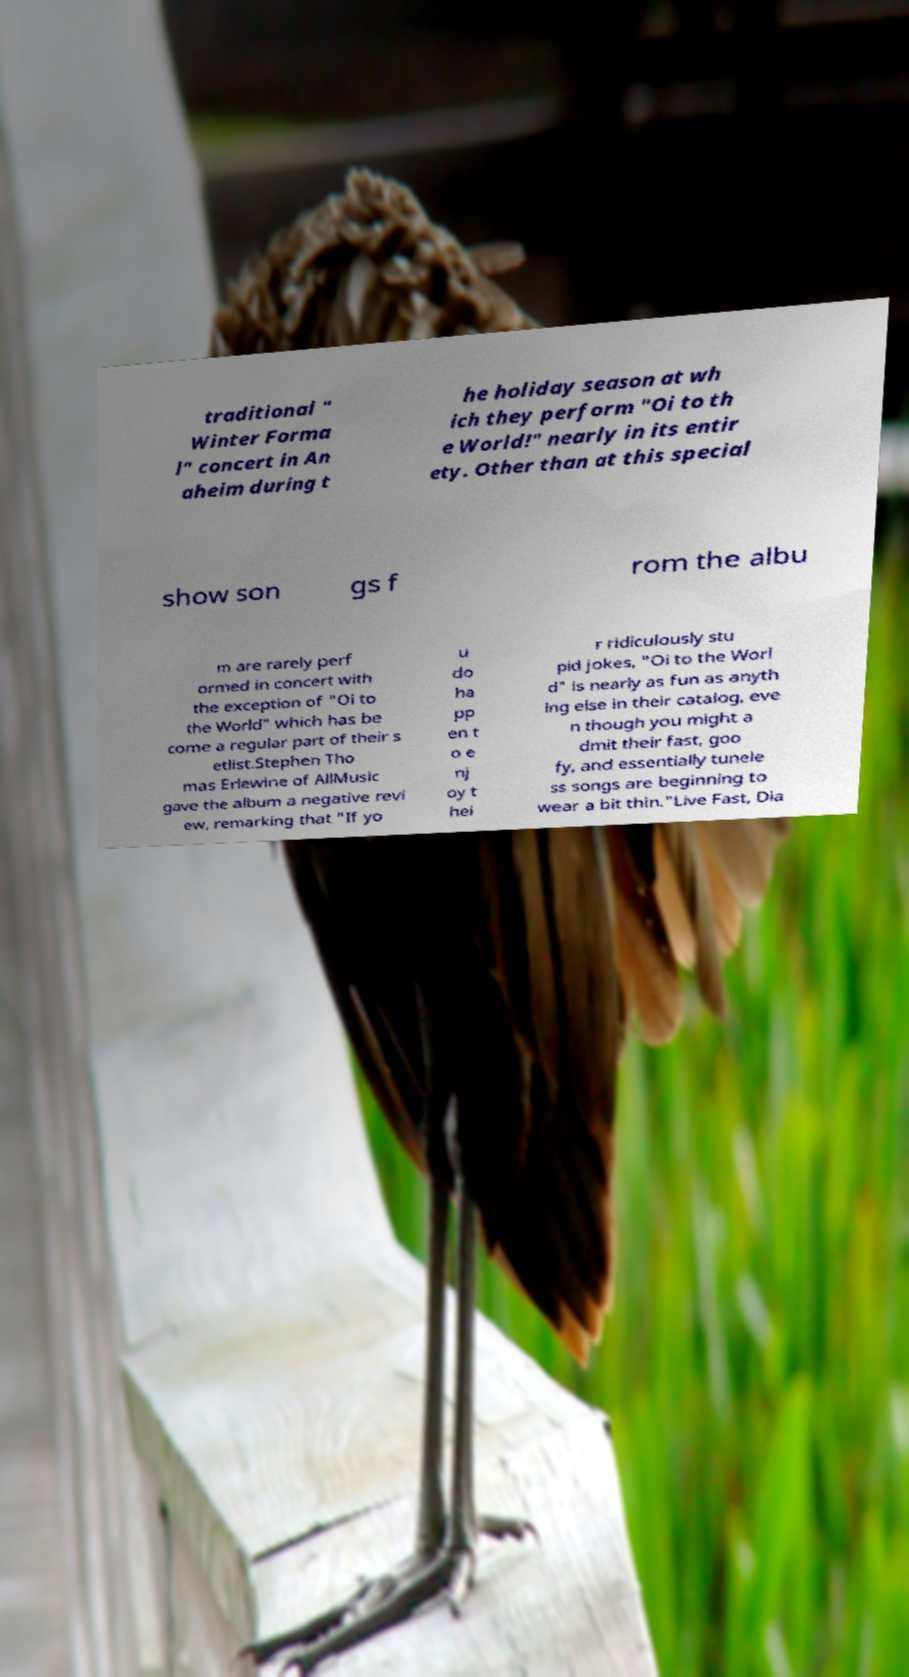I need the written content from this picture converted into text. Can you do that? traditional " Winter Forma l" concert in An aheim during t he holiday season at wh ich they perform "Oi to th e World!" nearly in its entir ety. Other than at this special show son gs f rom the albu m are rarely perf ormed in concert with the exception of "Oi to the World" which has be come a regular part of their s etlist.Stephen Tho mas Erlewine of AllMusic gave the album a negative revi ew, remarking that "If yo u do ha pp en t o e nj oy t hei r ridiculously stu pid jokes, "Oi to the Worl d" is nearly as fun as anyth ing else in their catalog, eve n though you might a dmit their fast, goo fy, and essentially tunele ss songs are beginning to wear a bit thin."Live Fast, Dia 